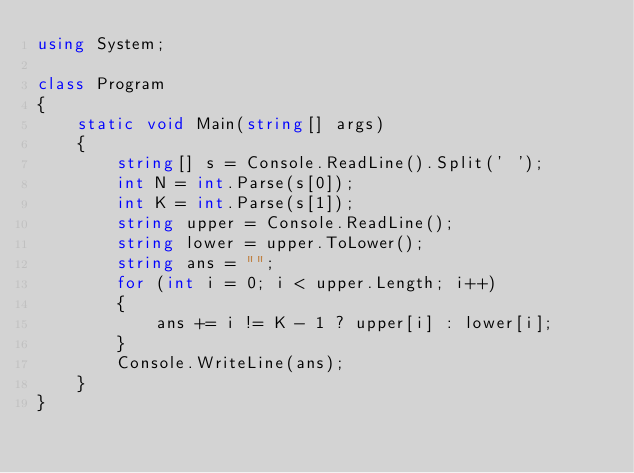Convert code to text. <code><loc_0><loc_0><loc_500><loc_500><_C#_>using System;

class Program
{
    static void Main(string[] args)
    {
        string[] s = Console.ReadLine().Split(' ');
        int N = int.Parse(s[0]);
        int K = int.Parse(s[1]);
        string upper = Console.ReadLine();
        string lower = upper.ToLower();
        string ans = "";
        for (int i = 0; i < upper.Length; i++)
        {
            ans += i != K - 1 ? upper[i] : lower[i];
        }
        Console.WriteLine(ans);
    }
}</code> 